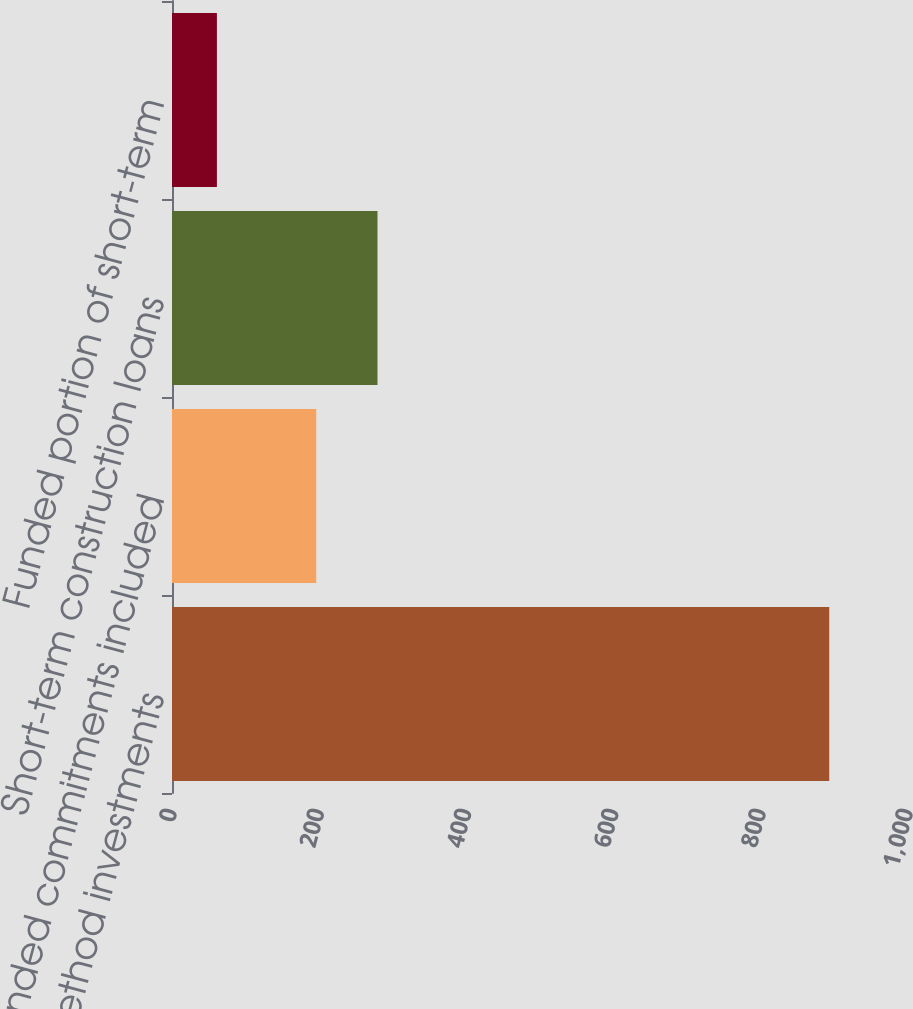Convert chart to OTSL. <chart><loc_0><loc_0><loc_500><loc_500><bar_chart><fcel>Equity method investments<fcel>Unfunded commitments included<fcel>Short-term construction loans<fcel>Funded portion of short-term<nl><fcel>893<fcel>196<fcel>279.2<fcel>61<nl></chart> 